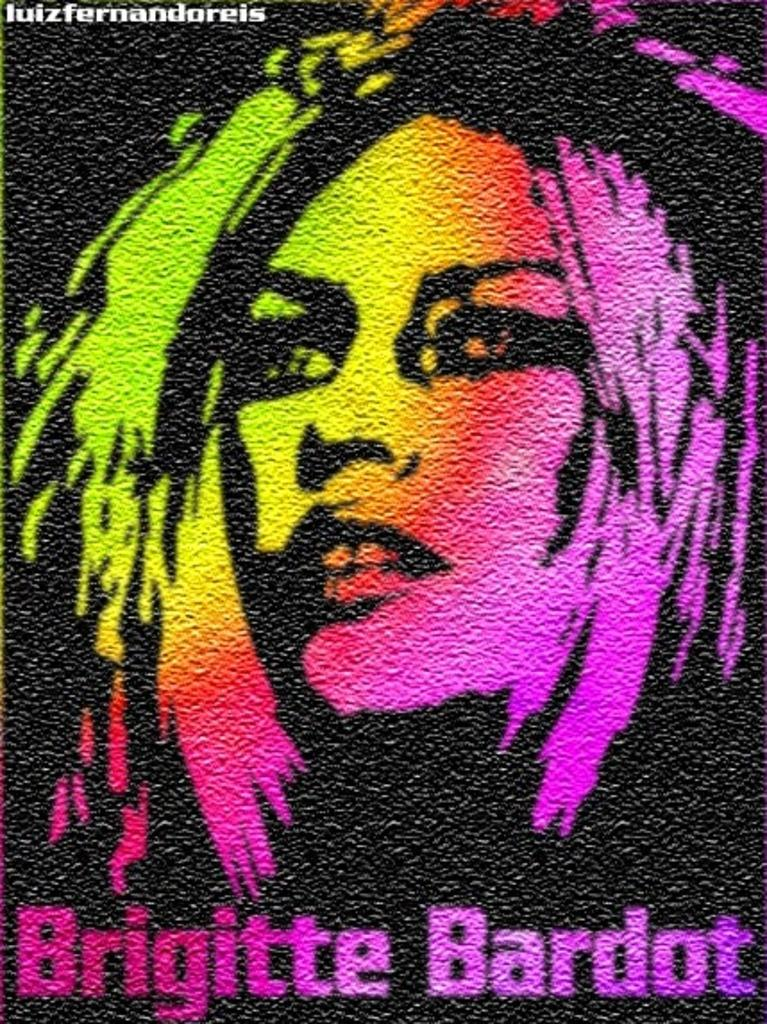What type of image is being described? The image is an edited picture. What can be seen in the edited picture? There is a picture of a person in the image. Where is the text located in the image? There is text at the top left and at the bottom of the image. What type of sticks are being used by the person in the image? There are no sticks visible in the image; it only features a picture of a person and text. What type of work is the person in the image doing? The image does not show the person performing any work or activity, so it cannot be determined from the image. 